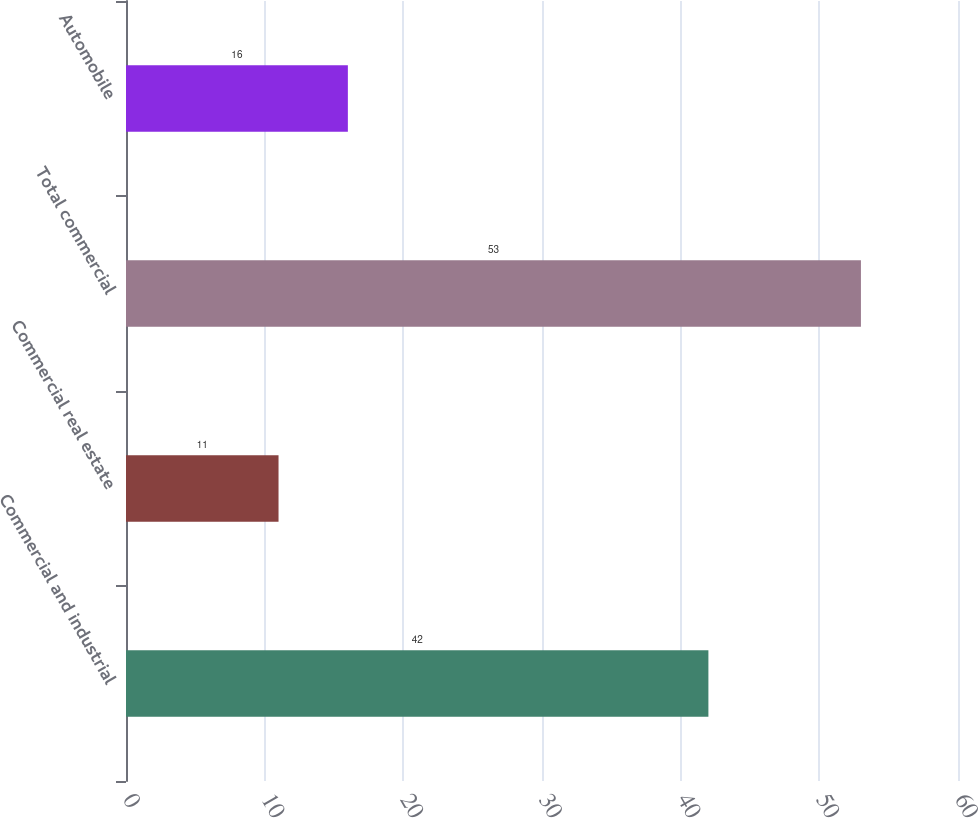Convert chart to OTSL. <chart><loc_0><loc_0><loc_500><loc_500><bar_chart><fcel>Commercial and industrial<fcel>Commercial real estate<fcel>Total commercial<fcel>Automobile<nl><fcel>42<fcel>11<fcel>53<fcel>16<nl></chart> 